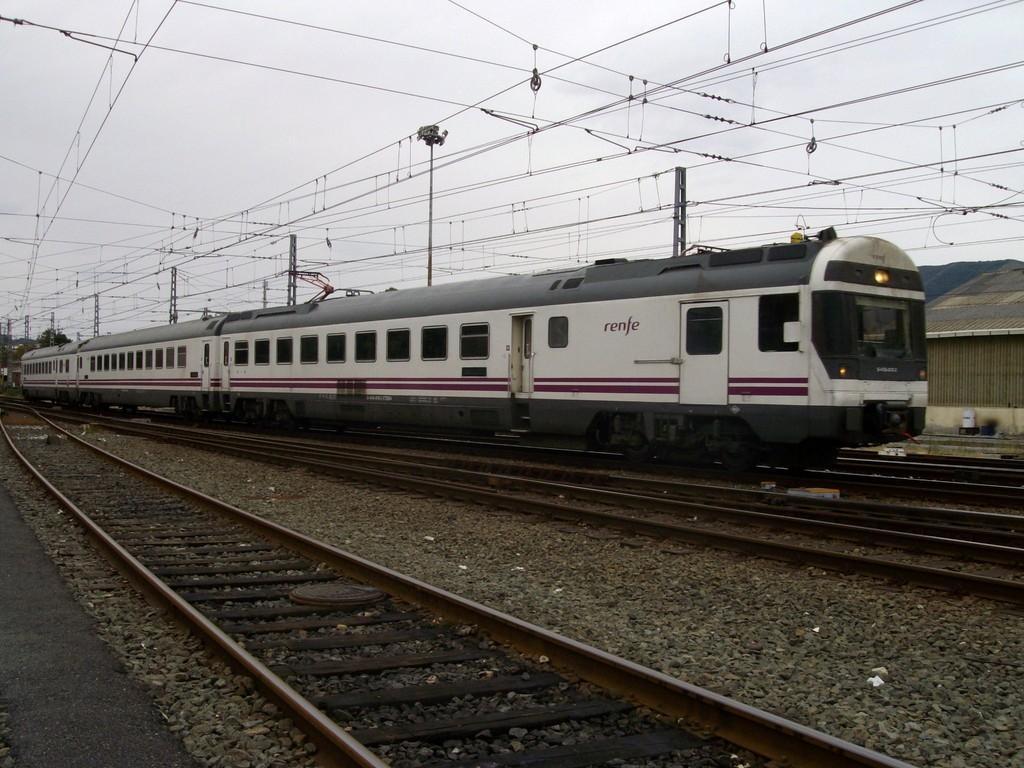In one or two sentences, can you explain what this image depicts? At the bottom of the image we can see some stones and tracks. In the middle of the image we can see a locomotive. Behind the locomotive there is a shed, poles and wires. At the top of the image there are some clouds in the sky. 